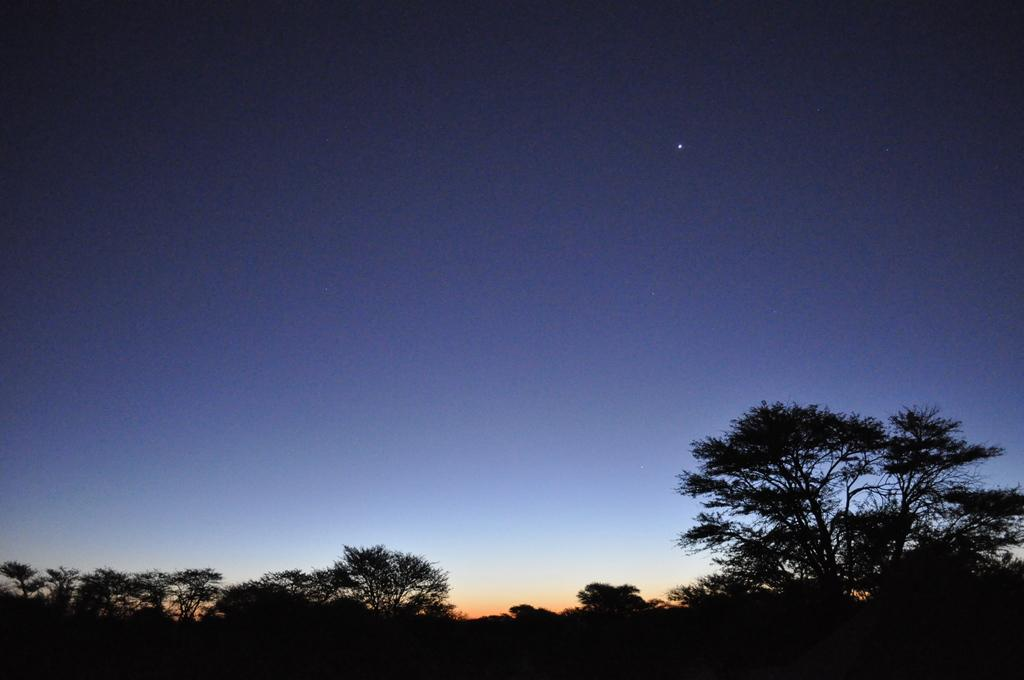What type of vegetation is present at the bottom of the image? There are trees at the bottom of the image. What part of the natural environment is visible in the background of the image? The sky is visible in the background of the image. What type of notebook can be seen on the tree trunk in the image? There is no notebook present in the image; it only features trees and the sky. 